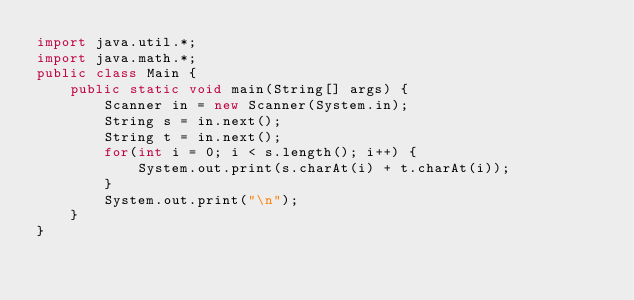Convert code to text. <code><loc_0><loc_0><loc_500><loc_500><_Java_>import java.util.*;
import java.math.*;
public class Main {
	public static void main(String[] args) {
		Scanner in = new Scanner(System.in);
		String s = in.next();
		String t = in.next();
		for(int i = 0; i < s.length(); i++) {
			System.out.print(s.charAt(i) + t.charAt(i));
		}
		System.out.print("\n");
	}
}</code> 